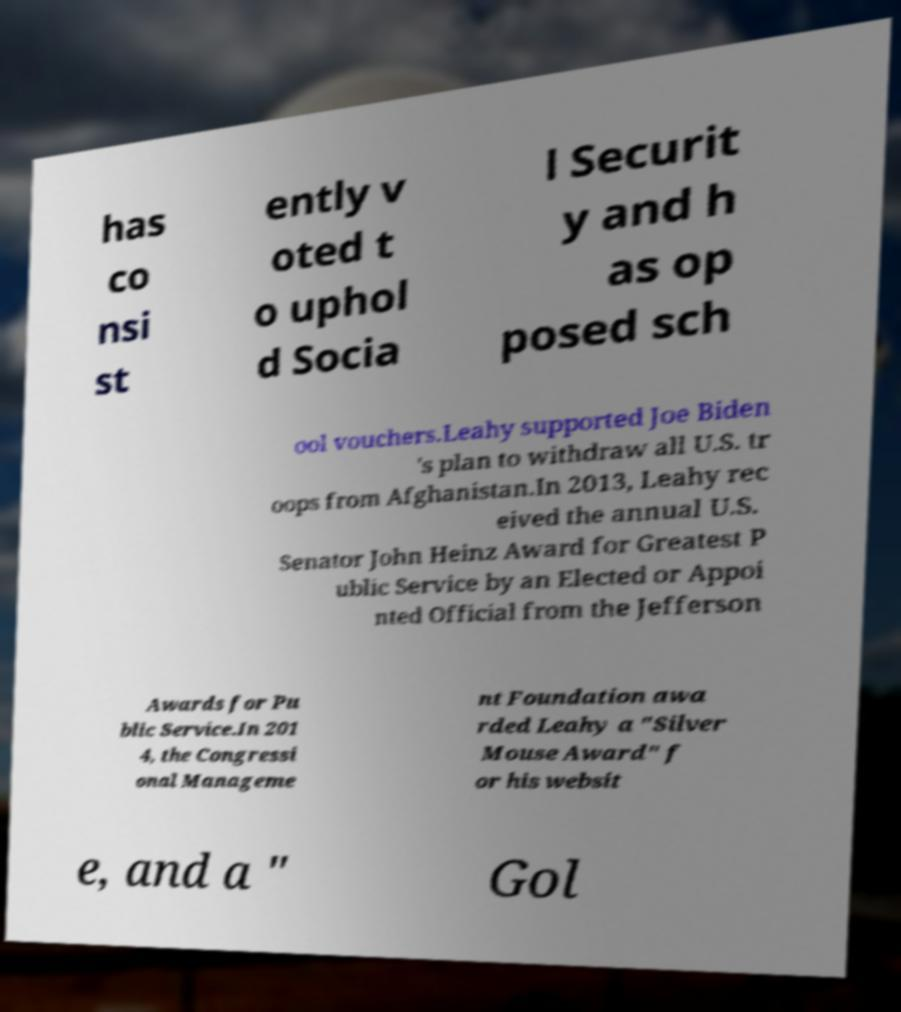Could you extract and type out the text from this image? has co nsi st ently v oted t o uphol d Socia l Securit y and h as op posed sch ool vouchers.Leahy supported Joe Biden 's plan to withdraw all U.S. tr oops from Afghanistan.In 2013, Leahy rec eived the annual U.S. Senator John Heinz Award for Greatest P ublic Service by an Elected or Appoi nted Official from the Jefferson Awards for Pu blic Service.In 201 4, the Congressi onal Manageme nt Foundation awa rded Leahy a "Silver Mouse Award" f or his websit e, and a " Gol 